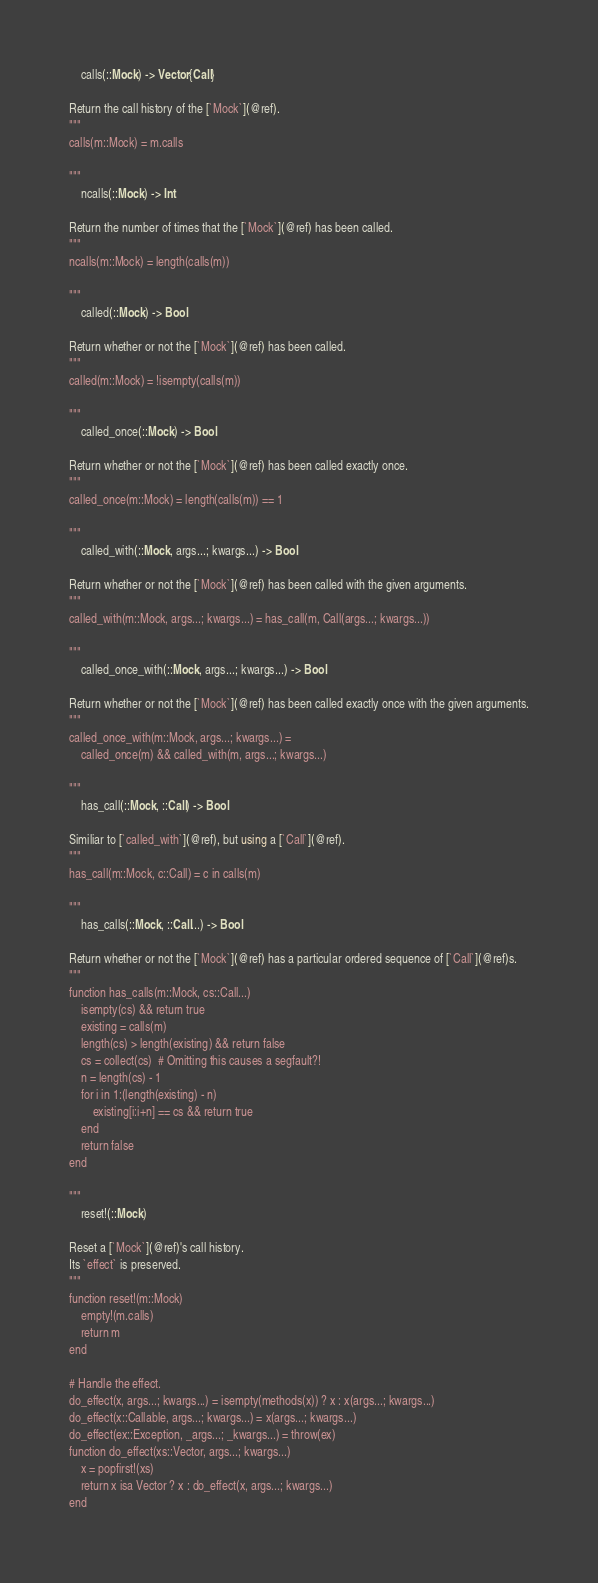Convert code to text. <code><loc_0><loc_0><loc_500><loc_500><_Julia_>    calls(::Mock) -> Vector{Call}

Return the call history of the [`Mock`](@ref).
"""
calls(m::Mock) = m.calls

"""
    ncalls(::Mock) -> Int

Return the number of times that the [`Mock`](@ref) has been called.
"""
ncalls(m::Mock) = length(calls(m))

"""
    called(::Mock) -> Bool

Return whether or not the [`Mock`](@ref) has been called.
"""
called(m::Mock) = !isempty(calls(m))

"""
    called_once(::Mock) -> Bool

Return whether or not the [`Mock`](@ref) has been called exactly once.
"""
called_once(m::Mock) = length(calls(m)) == 1

"""
    called_with(::Mock, args...; kwargs...) -> Bool

Return whether or not the [`Mock`](@ref) has been called with the given arguments.
"""
called_with(m::Mock, args...; kwargs...) = has_call(m, Call(args...; kwargs...))

"""
    called_once_with(::Mock, args...; kwargs...) -> Bool

Return whether or not the [`Mock`](@ref) has been called exactly once with the given arguments.
"""
called_once_with(m::Mock, args...; kwargs...) =
    called_once(m) && called_with(m, args...; kwargs...)

"""
    has_call(::Mock, ::Call) -> Bool

Similiar to [`called_with`](@ref), but using a [`Call`](@ref).
"""
has_call(m::Mock, c::Call) = c in calls(m)

"""
    has_calls(::Mock, ::Call...) -> Bool

Return whether or not the [`Mock`](@ref) has a particular ordered sequence of [`Call`](@ref)s.
"""
function has_calls(m::Mock, cs::Call...)
    isempty(cs) && return true
    existing = calls(m)
    length(cs) > length(existing) && return false
    cs = collect(cs)  # Omitting this causes a segfault?!
    n = length(cs) - 1
    for i in 1:(length(existing) - n)
        existing[i:i+n] == cs && return true
    end
    return false
end

"""
    reset!(::Mock)

Reset a [`Mock`](@ref)'s call history.
Its `effect` is preserved.
"""
function reset!(m::Mock)
    empty!(m.calls)
    return m
end

# Handle the effect.
do_effect(x, args...; kwargs...) = isempty(methods(x)) ? x : x(args...; kwargs...)
do_effect(x::Callable, args...; kwargs...) = x(args...; kwargs...)
do_effect(ex::Exception, _args...; _kwargs...) = throw(ex)
function do_effect(xs::Vector, args...; kwargs...)
    x = popfirst!(xs)
    return x isa Vector ? x : do_effect(x, args...; kwargs...)
end
</code> 